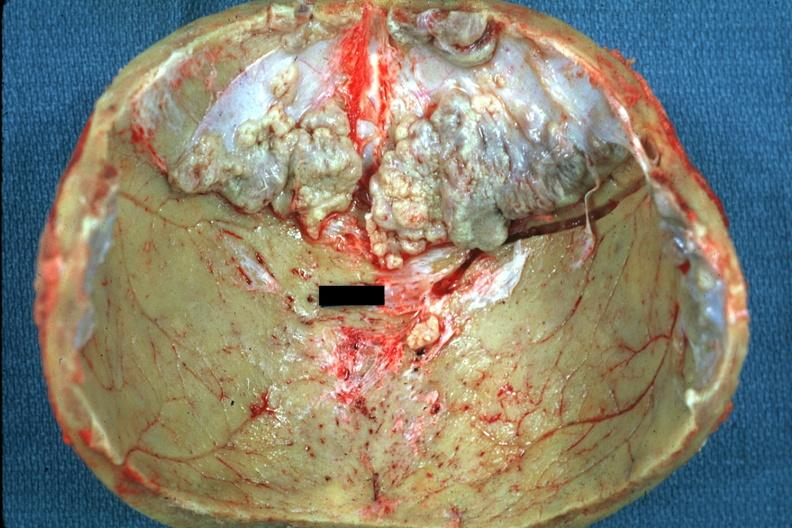what is present?
Answer the question using a single word or phrase. Bone 